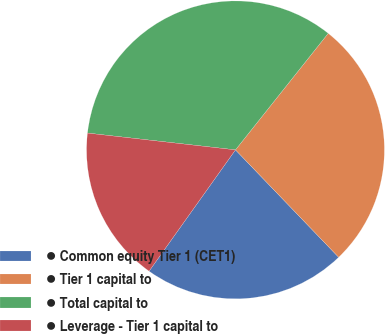Convert chart. <chart><loc_0><loc_0><loc_500><loc_500><pie_chart><fcel>● Common equity Tier 1 (CET1)<fcel>● Tier 1 capital to<fcel>● Total capital to<fcel>● Leverage - Tier 1 capital to<nl><fcel>22.03%<fcel>27.12%<fcel>33.9%<fcel>16.95%<nl></chart> 